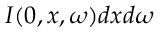Convert formula to latex. <formula><loc_0><loc_0><loc_500><loc_500>I ( 0 , x , \omega ) d x d \omega</formula> 